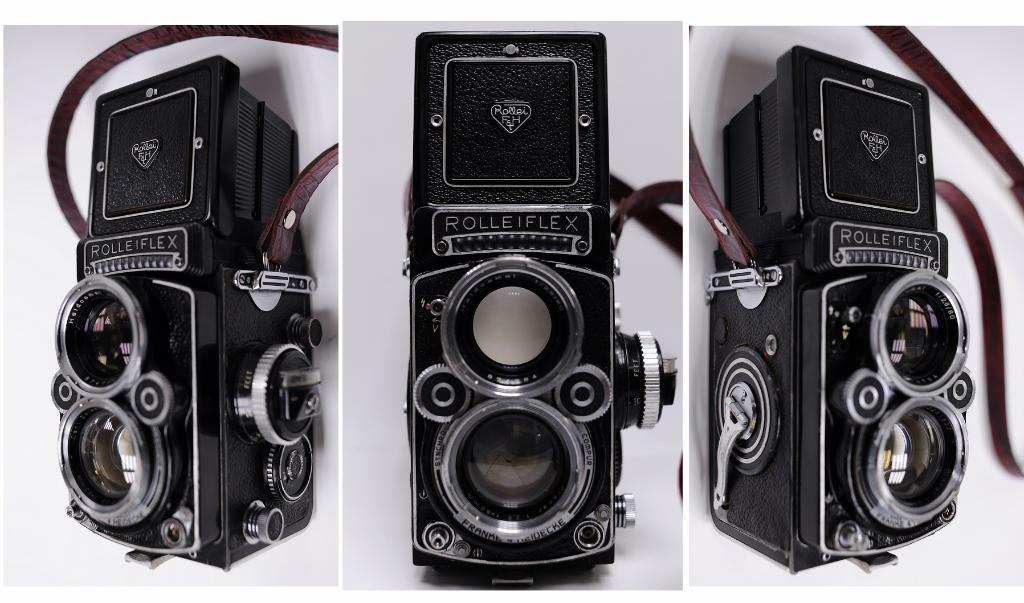How many objects can be seen in the image? There are three objects in the image. What is the color of the background in the image? The background of the image is white. How many rings are visible on the gate in the image? There is no gate or rings present in the image. What type of yard can be seen in the image? There is no yard present in the image. 